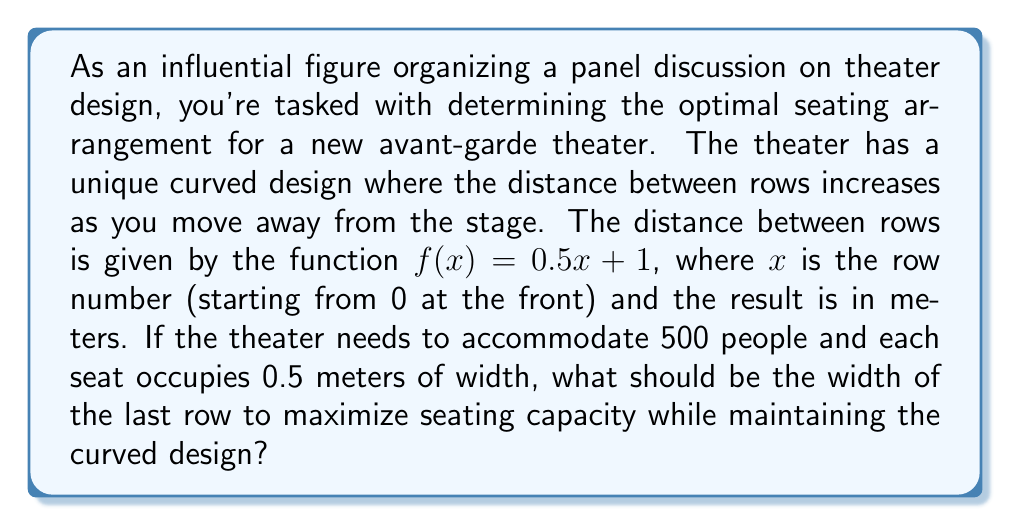Solve this math problem. Let's approach this step-by-step:

1) First, we need to set up an integral that represents the total area of the seating arrangement. The area function will be the product of the width (which we'll call $w(x)$) and the distance between rows $f(x)$.

2) The integral will be:

   $$A = \int_0^n w(x) \cdot f(x) dx$$

   where $n$ is the number of rows (which we don't know yet).

3) We're told that $f(x) = 0.5x + 1$. Let's assume the width function is linear, increasing from some initial width $a$ to a final width $b$:

   $$w(x) = a + \frac{b-a}{n}x$$

4) Substituting these into our integral:

   $$A = \int_0^n (a + \frac{b-a}{n}x)(0.5x + 1) dx$$

5) Expanding this:

   $$A = \int_0^n (0.5ax + a + 0.5\frac{b-a}{n}x^2 + \frac{b-a}{n}x) dx$$

6) Integrating:

   $$A = [0.25ax^2 + ax + \frac{b-a}{6n}x^3 + \frac{b-a}{2n}x^2]_0^n$$

7) Evaluating at the limits:

   $$A = 0.25an^2 + an + \frac{b-a}{6}n^2 + \frac{b-a}{2}n$$

8) We know that the total area should accommodate 500 people, with each person occupying 0.5 meters of width. So:

   $$A = 500 \cdot 0.5 = 250$$

9) We also know that $a$, the width of the first row, should be 500 · 0.5 / n = 250 / n.

10) Substituting these into our area equation:

    $$250 = 0.25(\frac{250}{n})n^2 + \frac{250}{n}n + \frac{b-\frac{250}{n}}{6}n^2 + \frac{b-\frac{250}{n}}{2}n$$

11) Simplifying:

    $$250 = 62.5n + 250 + \frac{bn^2}{6} - \frac{250n}{6} + \frac{bn}{2} - 125$$

12) Further simplifying:

    $$125 = 62.5n + \frac{bn^2}{6} + \frac{bn}{2} - \frac{250n}{6}$$

13) Solving this equation numerically (as it's a complex quadratic in terms of $n$), we get approximately:

    $n \approx 22$ rows
    $b \approx 16.7$ meters

Therefore, the width of the last row should be approximately 16.7 meters.
Answer: The width of the last row should be approximately 16.7 meters. 